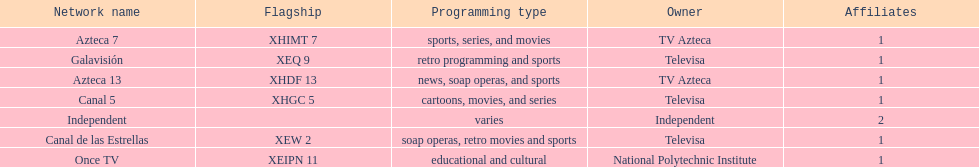Name a station that shows sports but is not televisa. Azteca 7. Would you mind parsing the complete table? {'header': ['Network name', 'Flagship', 'Programming type', 'Owner', 'Affiliates'], 'rows': [['Azteca 7', 'XHIMT 7', 'sports, series, and movies', 'TV Azteca', '1'], ['Galavisión', 'XEQ 9', 'retro programming and sports', 'Televisa', '1'], ['Azteca 13', 'XHDF 13', 'news, soap operas, and sports', 'TV Azteca', '1'], ['Canal 5', 'XHGC 5', 'cartoons, movies, and series', 'Televisa', '1'], ['Independent', '', 'varies', 'Independent', '2'], ['Canal de las Estrellas', 'XEW 2', 'soap operas, retro movies and sports', 'Televisa', '1'], ['Once TV', 'XEIPN 11', 'educational and cultural', 'National Polytechnic Institute', '1']]} 